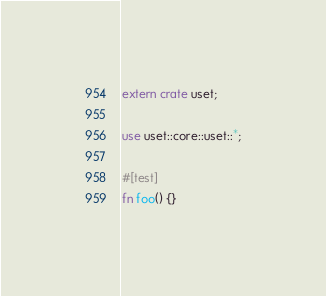Convert code to text. <code><loc_0><loc_0><loc_500><loc_500><_Rust_>extern crate uset;

use uset::core::uset::*;

#[test]
fn foo() {}
</code> 